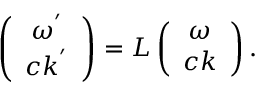Convert formula to latex. <formula><loc_0><loc_0><loc_500><loc_500>\begin{array} { r } { \left ( \begin{array} { c c } { \omega ^ { ^ { \prime } } } \\ { c k ^ { ^ { \prime } } } \end{array} \right ) = L \left ( \begin{array} { c c } { \omega } \\ { c k } \end{array} \right ) . } \end{array}</formula> 